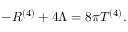Convert formula to latex. <formula><loc_0><loc_0><loc_500><loc_500>- R ^ { ( 4 ) } + 4 \Lambda = 8 \pi T ^ { ( 4 ) } .</formula> 